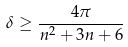Convert formula to latex. <formula><loc_0><loc_0><loc_500><loc_500>\delta \geq \frac { 4 \pi } { n ^ { 2 } + 3 n + 6 }</formula> 